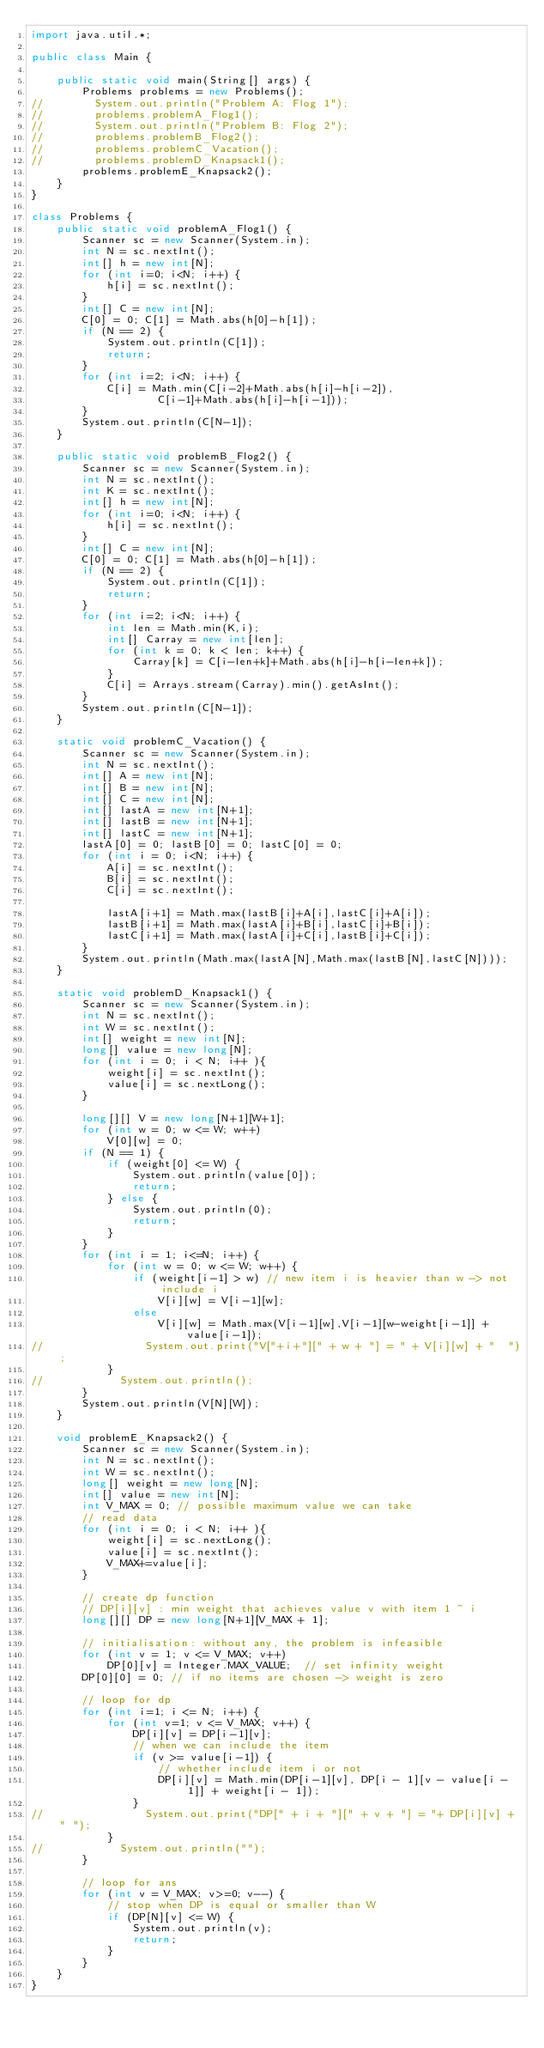<code> <loc_0><loc_0><loc_500><loc_500><_Java_>import java.util.*;

public class Main {

    public static void main(String[] args) {
        Problems problems = new Problems();
//        System.out.println("Problem A: Flog 1");
//        problems.problemA_Flog1();
//        System.out.println("Problem B: Flog 2");
//        problems.problemB_Flog2();
//        problems.problemC_Vacation();
//        problems.problemD_Knapsack1();
        problems.problemE_Knapsack2();
    }
}

class Problems {
    public static void problemA_Flog1() {
        Scanner sc = new Scanner(System.in);
        int N = sc.nextInt();
        int[] h = new int[N];
        for (int i=0; i<N; i++) {
            h[i] = sc.nextInt();
        }
        int[] C = new int[N];
        C[0] = 0; C[1] = Math.abs(h[0]-h[1]);
        if (N == 2) {
            System.out.println(C[1]);
            return;
        }
        for (int i=2; i<N; i++) {
            C[i] = Math.min(C[i-2]+Math.abs(h[i]-h[i-2]),
                    C[i-1]+Math.abs(h[i]-h[i-1]));
        }
        System.out.println(C[N-1]);
    }

    public static void problemB_Flog2() {
        Scanner sc = new Scanner(System.in);
        int N = sc.nextInt();
        int K = sc.nextInt();
        int[] h = new int[N];
        for (int i=0; i<N; i++) {
            h[i] = sc.nextInt();
        }
        int[] C = new int[N];
        C[0] = 0; C[1] = Math.abs(h[0]-h[1]);
        if (N == 2) {
            System.out.println(C[1]);
            return;
        }
        for (int i=2; i<N; i++) {
            int len = Math.min(K,i);
            int[] Carray = new int[len];
            for (int k = 0; k < len; k++) {
                Carray[k] = C[i-len+k]+Math.abs(h[i]-h[i-len+k]);
            }
            C[i] = Arrays.stream(Carray).min().getAsInt();
        }
        System.out.println(C[N-1]);
    }

    static void problemC_Vacation() {
        Scanner sc = new Scanner(System.in);
        int N = sc.nextInt();
        int[] A = new int[N];
        int[] B = new int[N];
        int[] C = new int[N];
        int[] lastA = new int[N+1];
        int[] lastB = new int[N+1];
        int[] lastC = new int[N+1];
        lastA[0] = 0; lastB[0] = 0; lastC[0] = 0;
        for (int i = 0; i<N; i++) {
            A[i] = sc.nextInt();
            B[i] = sc.nextInt();
            C[i] = sc.nextInt();

            lastA[i+1] = Math.max(lastB[i]+A[i],lastC[i]+A[i]);
            lastB[i+1] = Math.max(lastA[i]+B[i],lastC[i]+B[i]);
            lastC[i+1] = Math.max(lastA[i]+C[i],lastB[i]+C[i]);
        }
        System.out.println(Math.max(lastA[N],Math.max(lastB[N],lastC[N])));
    }

    static void problemD_Knapsack1() {
        Scanner sc = new Scanner(System.in);
        int N = sc.nextInt();
        int W = sc.nextInt();
        int[] weight = new int[N];
        long[] value = new long[N];
        for (int i = 0; i < N; i++ ){
            weight[i] = sc.nextInt();
            value[i] = sc.nextLong();
        }

        long[][] V = new long[N+1][W+1];
        for (int w = 0; w <= W; w++)
            V[0][w] = 0;
        if (N == 1) {
            if (weight[0] <= W) {
                System.out.println(value[0]);
                return;
            } else {
                System.out.println(0);
                return;
            }
        }
        for (int i = 1; i<=N; i++) {
            for (int w = 0; w <= W; w++) {
                if (weight[i-1] > w) // new item i is heavier than w -> not include i
                    V[i][w] = V[i-1][w];
                else
                    V[i][w] = Math.max(V[i-1][w],V[i-1][w-weight[i-1]] + value[i-1]);
//                System.out.print("V["+i+"][" + w + "] = " + V[i][w] + "  ");
            }
//            System.out.println();
        }
        System.out.println(V[N][W]);
    }

    void problemE_Knapsack2() {
        Scanner sc = new Scanner(System.in);
        int N = sc.nextInt();
        int W = sc.nextInt();
        long[] weight = new long[N];
        int[] value = new int[N];
        int V_MAX = 0; // possible maximum value we can take
        // read data
        for (int i = 0; i < N; i++ ){
            weight[i] = sc.nextLong();
            value[i] = sc.nextInt();
            V_MAX+=value[i];
        }

        // create dp function
        // DP[i][v] : min weight that achieves value v with item 1 ~ i
        long[][] DP = new long[N+1][V_MAX + 1];

        // initialisation: without any, the problem is infeasible
        for (int v = 1; v <= V_MAX; v++)
            DP[0][v] = Integer.MAX_VALUE;  // set infinity weight
        DP[0][0] = 0; // if no items are chosen -> weight is zero
        
        // loop for dp
        for (int i=1; i <= N; i++) {
            for (int v=1; v <= V_MAX; v++) {
                DP[i][v] = DP[i-1][v];
                // when we can include the item
                if (v >= value[i-1]) {
                    // whether include item i or not
                    DP[i][v] = Math.min(DP[i-1][v], DP[i - 1][v - value[i - 1]] + weight[i - 1]);
                }
//                System.out.print("DP[" + i + "][" + v + "] = "+ DP[i][v] + " ");
            }
//            System.out.println("");
        }

        // loop for ans
        for (int v = V_MAX; v>=0; v--) {
            // stop when DP is equal or smaller than W
            if (DP[N][v] <= W) {
                System.out.println(v);
                return;
            }
        }
    }
}</code> 